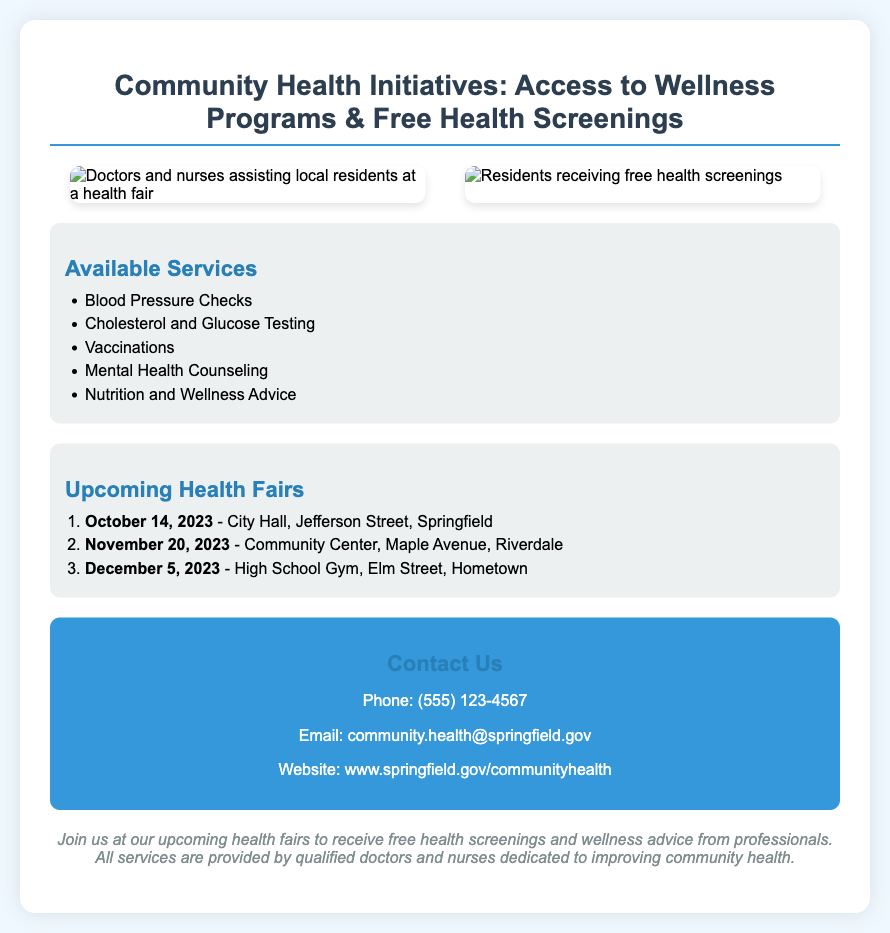What is the title of the poster? The title of the poster is clearly stated at the top of the document, emphasizing the purpose and theme of the community health initiatives.
Answer: Community Health Initiatives: Access to Wellness Programs & Free Health Screenings When is the first health fair scheduled? The first health fair is listed under the upcoming health fairs section with its specific date and location, making it easy to find this information.
Answer: October 14, 2023 Where will the health fair on November 20, 2023, be held? The location for the health fair on November 20, 2023, is provided in the invitation section, detailing what community center will host it.
Answer: Community Center, Maple Avenue, Riverdale What service is not listed among the available services? By analyzing the list of available services, one can identify which particular health service is omitted from the poster.
Answer: Dental Check-ups How many health fairs are mentioned in the document? The total number of health fairs is obtained from counting the entries listed in the upcoming health fairs section.
Answer: Three What type of professionals will provide services at the health fairs? The document specifies the type of personnel involved in delivering health services during the health fairs.
Answer: Qualified doctors and nurses What is the phone number to contact for more information? The contact section of the document includes specific contact information like phone number, making it easy to retrieve this.
Answer: (555) 123-4567 Which service offers nutrition advice? The list of available services explicitly mentions services related to dietary or nutritional guidance, indicating that it is available.
Answer: Nutrition and Wellness Advice 